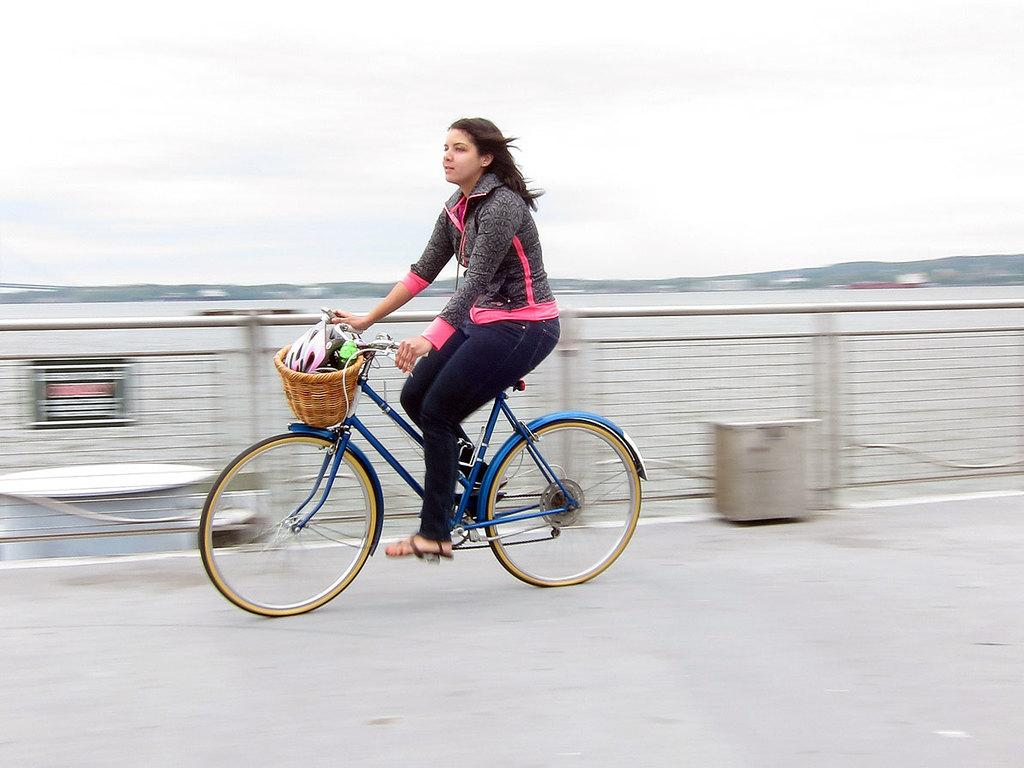Who is the main subject in the image? There is a woman in the image. What is the woman doing in the image? The woman is on a bicycle. What can be seen in the background of the image? The sky is visible in the background of the image. What type of environment is depicted in the image? There is a road, a fence, and water visible in the image, suggesting an outdoor setting. What type of statement can be seen written on the crate in the image? There is no crate present in the image, so no statement can be seen written on it. 